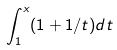<formula> <loc_0><loc_0><loc_500><loc_500>\int _ { 1 } ^ { x } ( 1 + 1 / t ) d t</formula> 